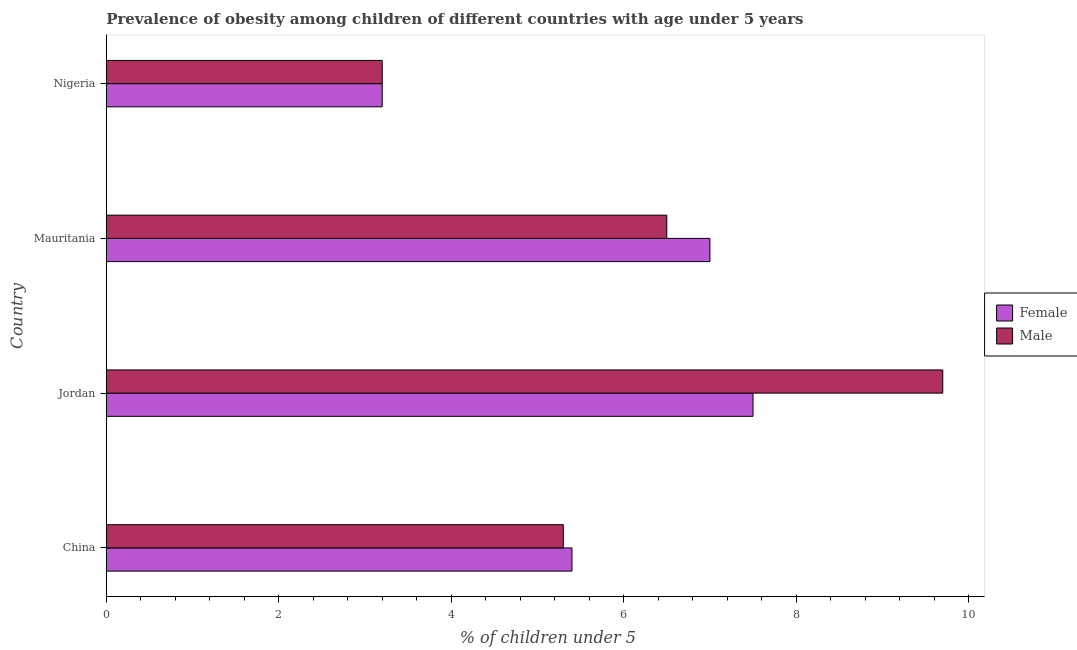How many different coloured bars are there?
Provide a short and direct response. 2. Are the number of bars per tick equal to the number of legend labels?
Ensure brevity in your answer.  Yes. Are the number of bars on each tick of the Y-axis equal?
Give a very brief answer. Yes. How many bars are there on the 4th tick from the top?
Provide a short and direct response. 2. How many bars are there on the 2nd tick from the bottom?
Your answer should be compact. 2. What is the label of the 2nd group of bars from the top?
Make the answer very short. Mauritania. What is the percentage of obese female children in Jordan?
Provide a succinct answer. 7.5. Across all countries, what is the maximum percentage of obese male children?
Ensure brevity in your answer.  9.7. Across all countries, what is the minimum percentage of obese female children?
Give a very brief answer. 3.2. In which country was the percentage of obese female children maximum?
Your answer should be compact. Jordan. In which country was the percentage of obese female children minimum?
Make the answer very short. Nigeria. What is the total percentage of obese female children in the graph?
Make the answer very short. 23.1. What is the difference between the percentage of obese female children in China and that in Jordan?
Ensure brevity in your answer.  -2.1. What is the difference between the percentage of obese male children in Nigeria and the percentage of obese female children in Mauritania?
Ensure brevity in your answer.  -3.8. What is the average percentage of obese male children per country?
Offer a very short reply. 6.17. What is the ratio of the percentage of obese female children in Jordan to that in Mauritania?
Your answer should be compact. 1.07. Is the percentage of obese male children in Jordan less than that in Nigeria?
Make the answer very short. No. Is the difference between the percentage of obese female children in Jordan and Mauritania greater than the difference between the percentage of obese male children in Jordan and Mauritania?
Make the answer very short. No. In how many countries, is the percentage of obese female children greater than the average percentage of obese female children taken over all countries?
Give a very brief answer. 2. Is the sum of the percentage of obese male children in China and Mauritania greater than the maximum percentage of obese female children across all countries?
Provide a succinct answer. Yes. What does the 2nd bar from the top in China represents?
Provide a succinct answer. Female. What does the 2nd bar from the bottom in China represents?
Offer a terse response. Male. How many bars are there?
Ensure brevity in your answer.  8. Are the values on the major ticks of X-axis written in scientific E-notation?
Offer a very short reply. No. Does the graph contain grids?
Keep it short and to the point. No. How many legend labels are there?
Your response must be concise. 2. How are the legend labels stacked?
Give a very brief answer. Vertical. What is the title of the graph?
Your answer should be very brief. Prevalence of obesity among children of different countries with age under 5 years. What is the label or title of the X-axis?
Give a very brief answer.  % of children under 5. What is the  % of children under 5 in Female in China?
Offer a very short reply. 5.4. What is the  % of children under 5 of Male in China?
Your answer should be very brief. 5.3. What is the  % of children under 5 in Female in Jordan?
Offer a very short reply. 7.5. What is the  % of children under 5 in Male in Jordan?
Make the answer very short. 9.7. What is the  % of children under 5 of Female in Mauritania?
Offer a very short reply. 7. What is the  % of children under 5 of Male in Mauritania?
Provide a short and direct response. 6.5. What is the  % of children under 5 in Female in Nigeria?
Offer a very short reply. 3.2. What is the  % of children under 5 of Male in Nigeria?
Give a very brief answer. 3.2. Across all countries, what is the maximum  % of children under 5 in Male?
Give a very brief answer. 9.7. Across all countries, what is the minimum  % of children under 5 of Female?
Offer a terse response. 3.2. Across all countries, what is the minimum  % of children under 5 in Male?
Provide a short and direct response. 3.2. What is the total  % of children under 5 in Female in the graph?
Provide a short and direct response. 23.1. What is the total  % of children under 5 in Male in the graph?
Offer a terse response. 24.7. What is the difference between the  % of children under 5 of Male in China and that in Jordan?
Make the answer very short. -4.4. What is the difference between the  % of children under 5 in Female in China and that in Nigeria?
Provide a short and direct response. 2.2. What is the difference between the  % of children under 5 of Male in Jordan and that in Mauritania?
Your response must be concise. 3.2. What is the difference between the  % of children under 5 in Female in China and the  % of children under 5 in Male in Jordan?
Give a very brief answer. -4.3. What is the difference between the  % of children under 5 in Female in China and the  % of children under 5 in Male in Mauritania?
Offer a terse response. -1.1. What is the average  % of children under 5 in Female per country?
Your answer should be compact. 5.78. What is the average  % of children under 5 of Male per country?
Provide a short and direct response. 6.17. What is the difference between the  % of children under 5 of Female and  % of children under 5 of Male in Jordan?
Your answer should be compact. -2.2. What is the difference between the  % of children under 5 in Female and  % of children under 5 in Male in Nigeria?
Offer a terse response. 0. What is the ratio of the  % of children under 5 of Female in China to that in Jordan?
Offer a very short reply. 0.72. What is the ratio of the  % of children under 5 in Male in China to that in Jordan?
Keep it short and to the point. 0.55. What is the ratio of the  % of children under 5 of Female in China to that in Mauritania?
Keep it short and to the point. 0.77. What is the ratio of the  % of children under 5 in Male in China to that in Mauritania?
Give a very brief answer. 0.82. What is the ratio of the  % of children under 5 in Female in China to that in Nigeria?
Provide a succinct answer. 1.69. What is the ratio of the  % of children under 5 of Male in China to that in Nigeria?
Offer a terse response. 1.66. What is the ratio of the  % of children under 5 of Female in Jordan to that in Mauritania?
Provide a succinct answer. 1.07. What is the ratio of the  % of children under 5 in Male in Jordan to that in Mauritania?
Give a very brief answer. 1.49. What is the ratio of the  % of children under 5 of Female in Jordan to that in Nigeria?
Offer a very short reply. 2.34. What is the ratio of the  % of children under 5 of Male in Jordan to that in Nigeria?
Offer a very short reply. 3.03. What is the ratio of the  % of children under 5 in Female in Mauritania to that in Nigeria?
Your answer should be very brief. 2.19. What is the ratio of the  % of children under 5 in Male in Mauritania to that in Nigeria?
Provide a succinct answer. 2.03. What is the difference between the highest and the lowest  % of children under 5 in Male?
Ensure brevity in your answer.  6.5. 